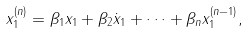<formula> <loc_0><loc_0><loc_500><loc_500>x _ { 1 } ^ { ( n ) } = \beta _ { 1 } x _ { 1 } + \beta _ { 2 } \dot { x } _ { 1 } + \cdots + \beta _ { n } x _ { 1 } ^ { ( n - 1 ) } ,</formula> 